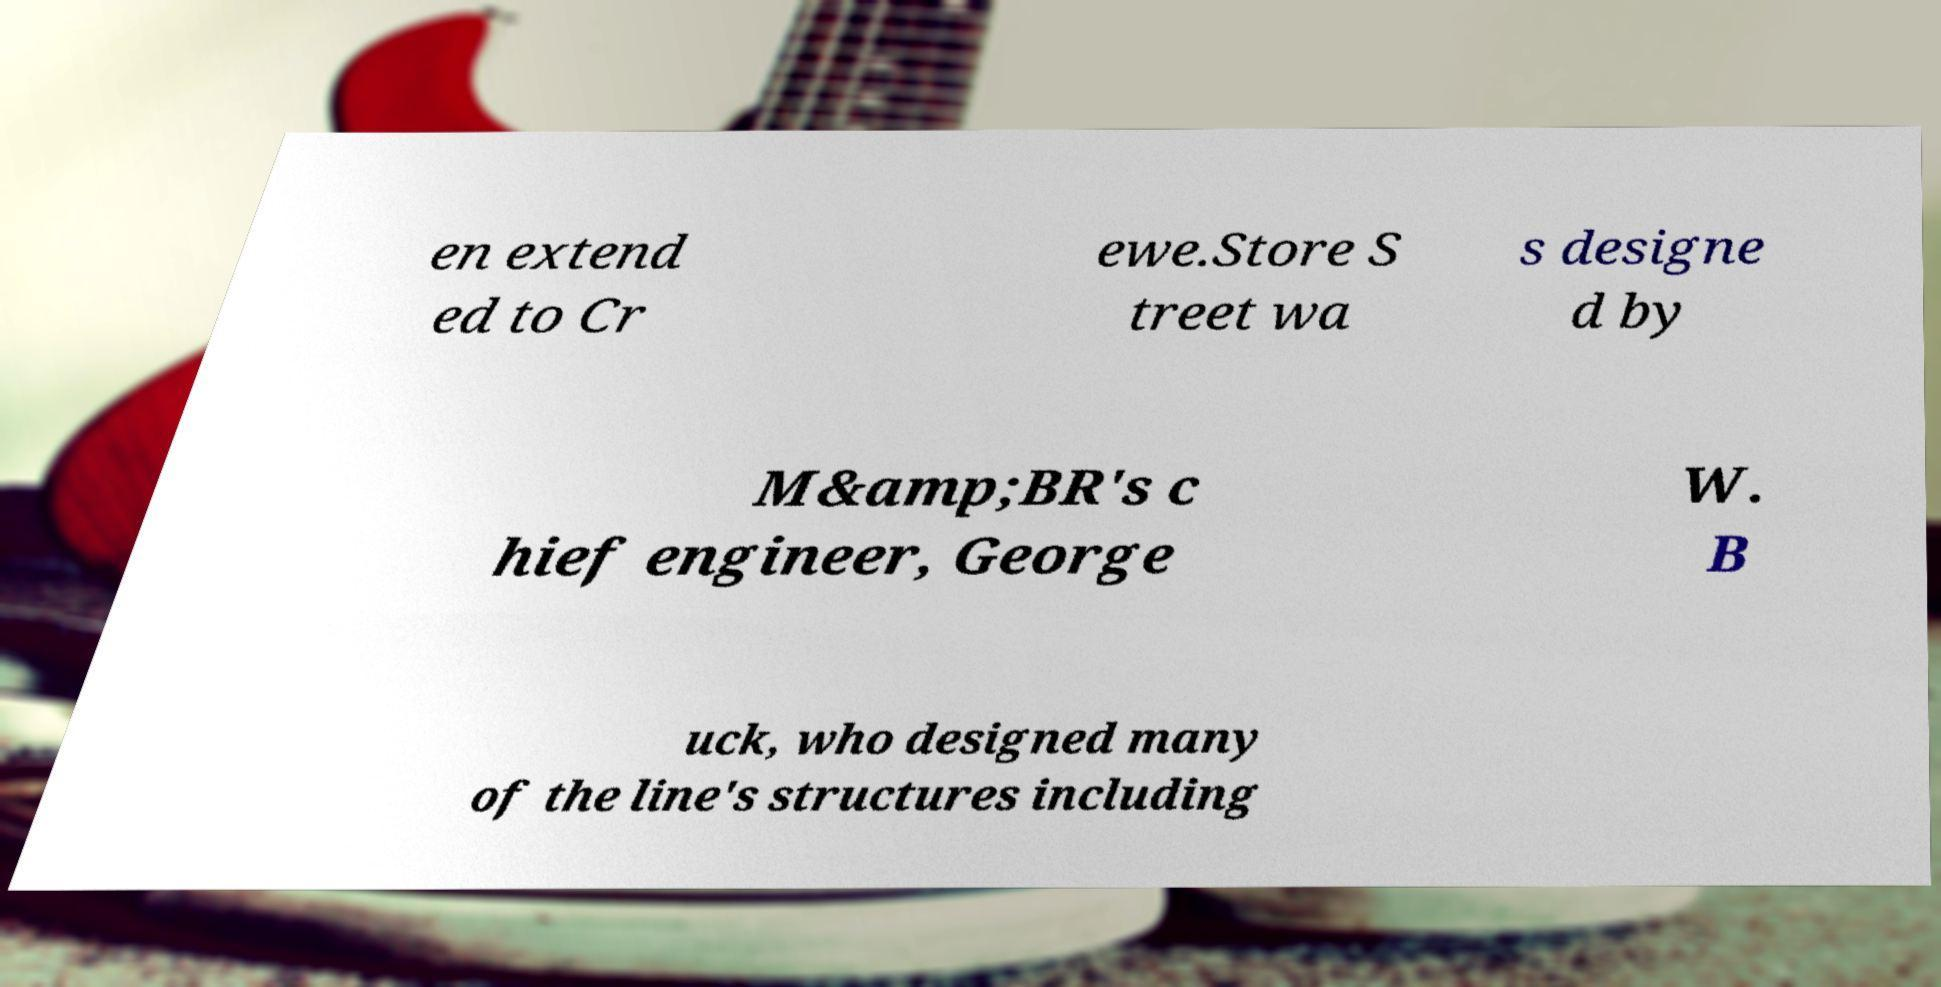What messages or text are displayed in this image? I need them in a readable, typed format. en extend ed to Cr ewe.Store S treet wa s designe d by M&amp;BR's c hief engineer, George W. B uck, who designed many of the line's structures including 